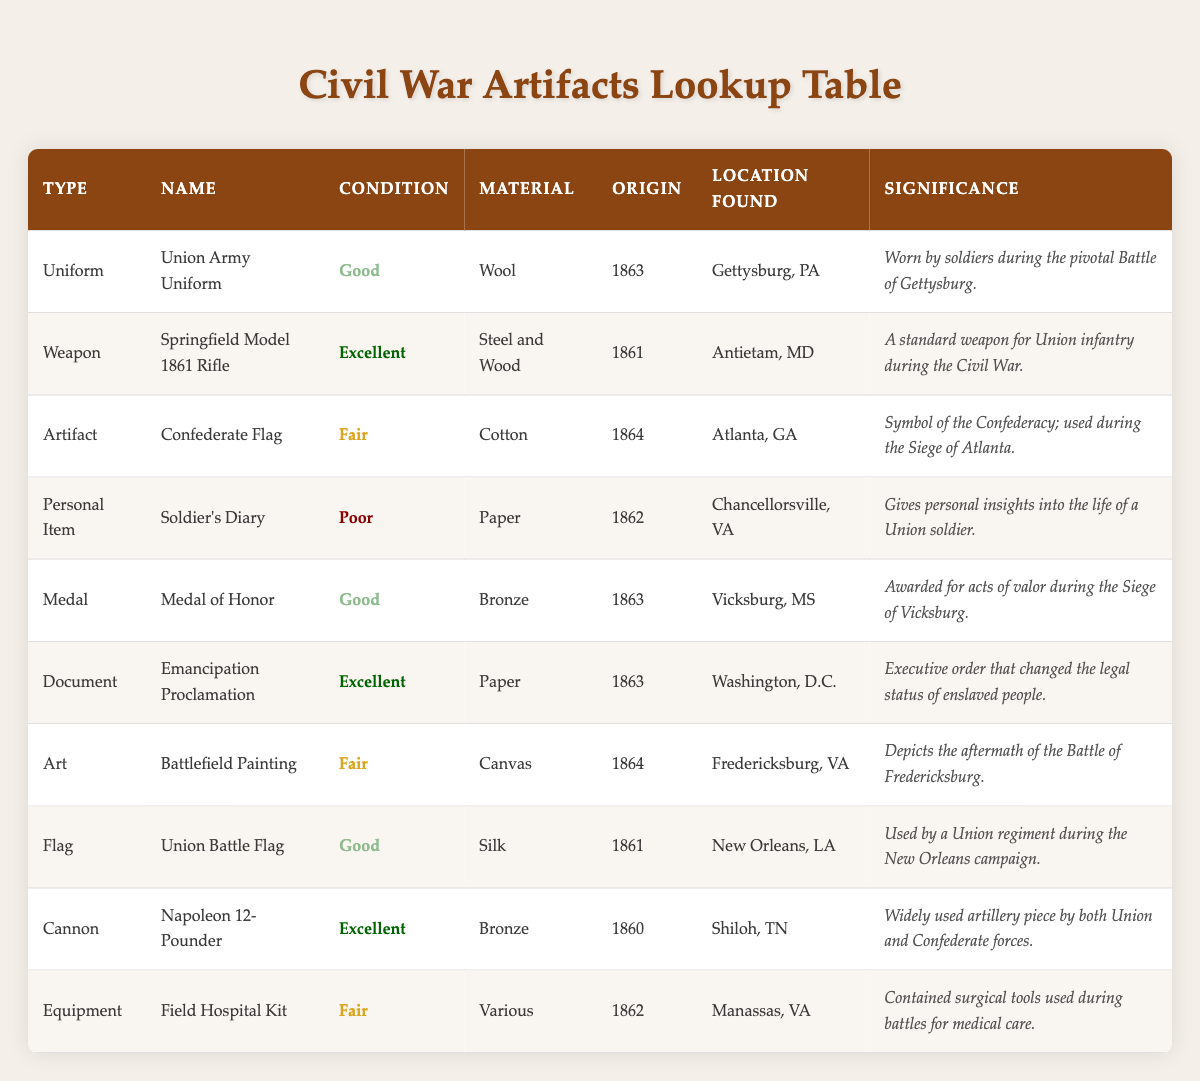What is the significance of the Union Army Uniform? The Union Army Uniform is significant as it was worn by soldiers during the pivotal Battle of Gettysburg, which is one of the most critical battles of the Civil War.
Answer: Worn by soldiers during the pivotal Battle of Gettysburg How many artifacts are listed in the table? There are a total of 10 artifacts listed in the table, as counted in the rows of the table excluding the header.
Answer: 10 Which artifact has the best condition? The artifacts with the best condition (Excellent) are the Springfield Model 1861 Rifle, Emancipation Proclamation, and Napoleon 12-Pounder, all marked with "Excellent" in the condition column.
Answer: Springfield Model 1861 Rifle, Emancipation Proclamation, Napoleon 12-Pounder What type of items are found in good condition? The items found in good condition are the Union Army Uniform, Medal of Honor, and Union Battle Flag. They are categorized under the "Good" condition in the table.
Answer: Union Army Uniform, Medal of Honor, Union Battle Flag Is the Soldier's Diary in excellent condition? No, the Soldier's Diary is in poor condition as indicated in the condition column of the table.
Answer: No What material is used for the Union Battle Flag? The material used for the Union Battle Flag is silk, which is stated in the material column for that specific artifact.
Answer: Silk Which artifact was awarded for acts of valor? The Medal of Honor was awarded for acts of valor during the Siege of Vicksburg, as described in its significance in the table.
Answer: Medal of Honor How many different artifact types have a "Fair" condition? There are three artifact types listed in "Fair" condition: Confederate Flag, Battlefield Painting, and Field Hospital Kit, totaling three distinct items.
Answer: 3 Which artifact represents a document related to freedom? The Emancipation Proclamation represents a document related to freedom, as it is an executive order that changed the legal status of enslaved people.
Answer: Emancipation Proclamation 